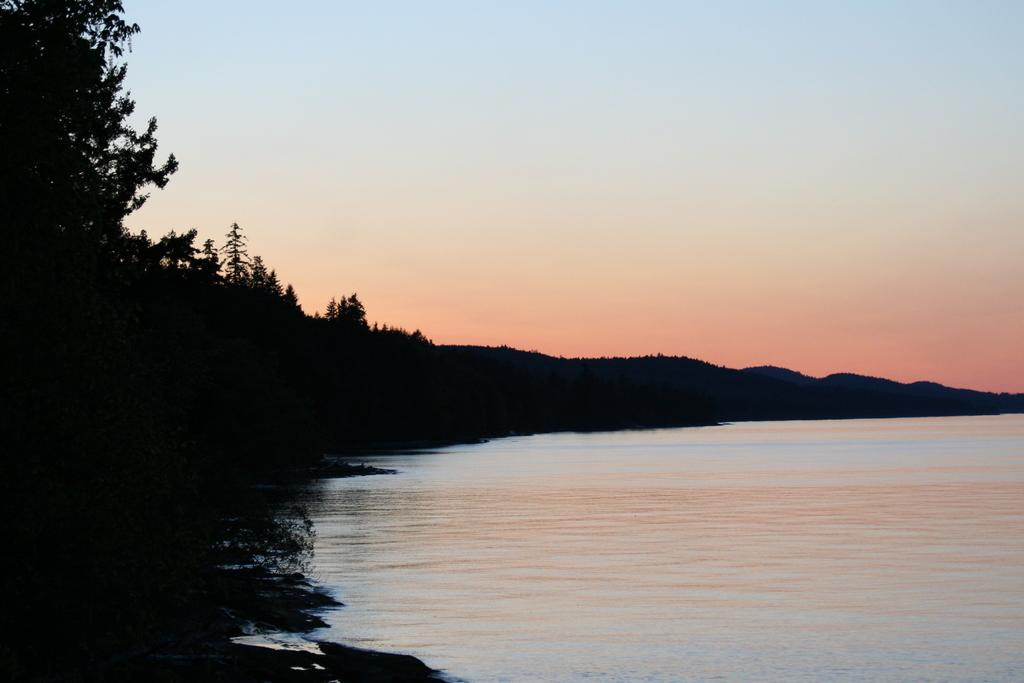What type of natural features can be seen in the image? There are trees and mountains visible in the image. What else can be seen in the image besides the trees and mountains? There is water visible in the image. What is visible in the background of the image? The sky is visible in the background of the image. What type of alley can be seen in the image? There is no alley present in the image; it features natural elements such as trees, mountains, water, and the sky. 